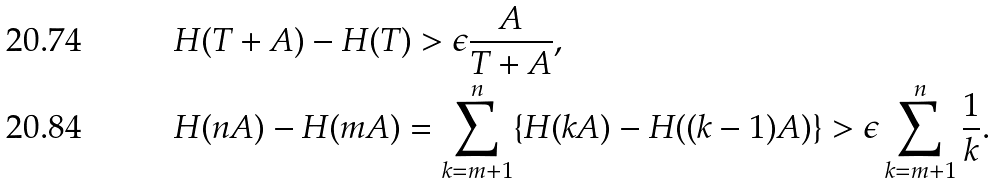Convert formula to latex. <formula><loc_0><loc_0><loc_500><loc_500>& H ( T + A ) - H ( T ) > \epsilon \frac { A } { T + A } , \\ & H ( n A ) - H ( m A ) = \sum _ { k = m + 1 } ^ { n } \{ H ( k A ) - H ( ( k - 1 ) A ) \} > \epsilon \sum _ { k = m + 1 } ^ { n } \frac { 1 } { k } .</formula> 